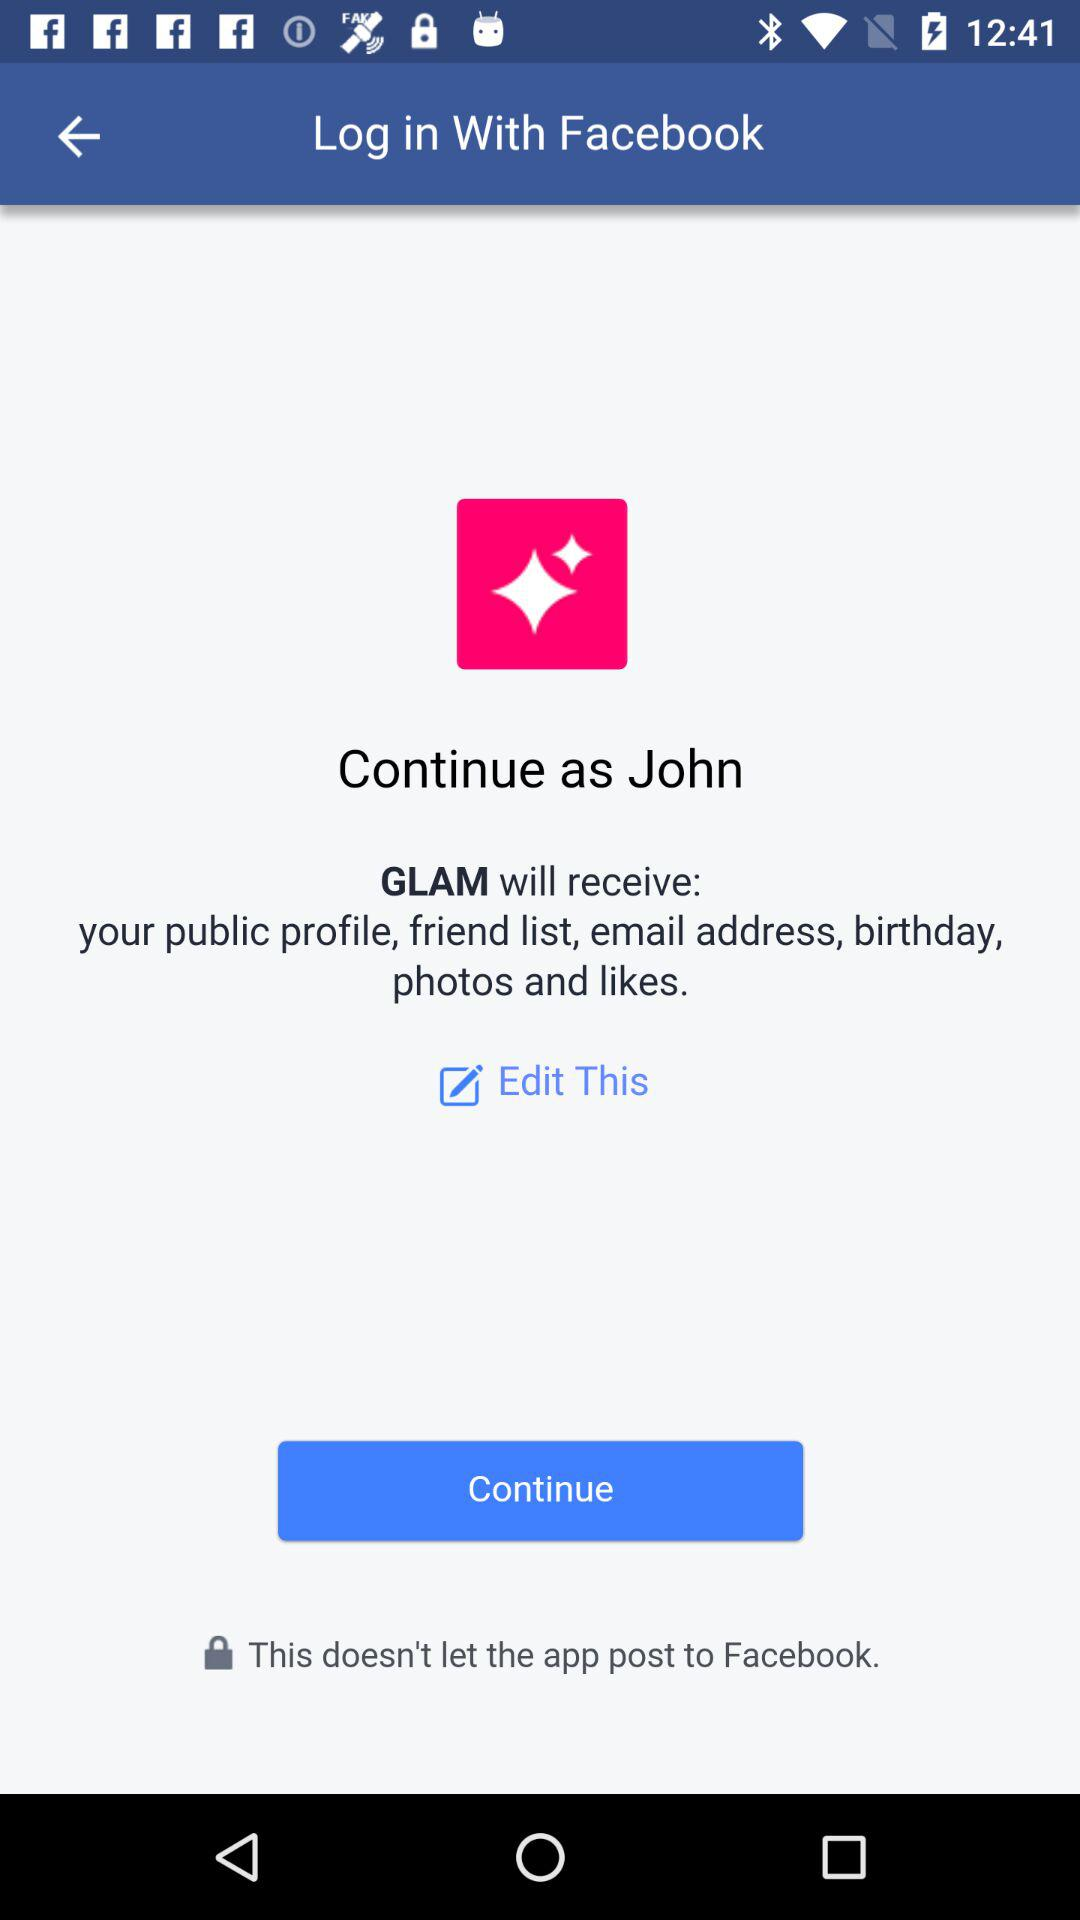What application is asking for permission? The application asking for permission is "GLAM". 